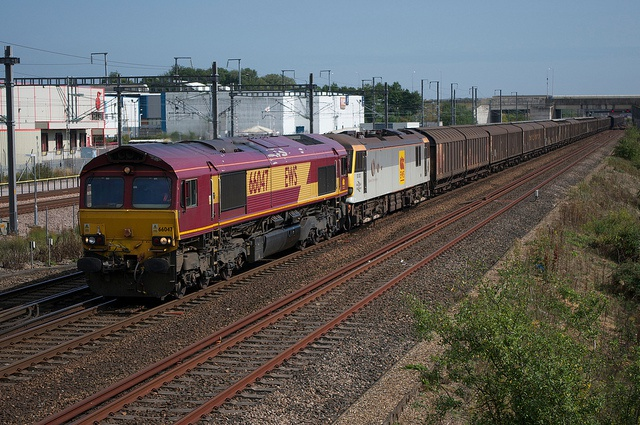Describe the objects in this image and their specific colors. I can see a train in gray, black, and maroon tones in this image. 